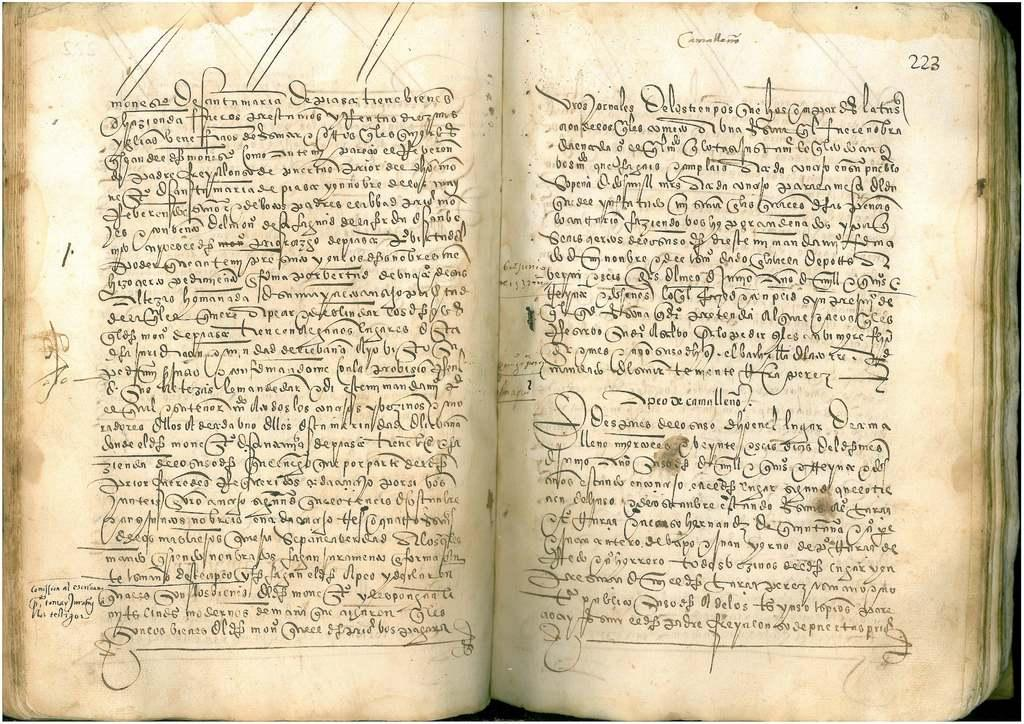<image>
Summarize the visual content of the image. a book with the number for the page 223 at the top of it. 